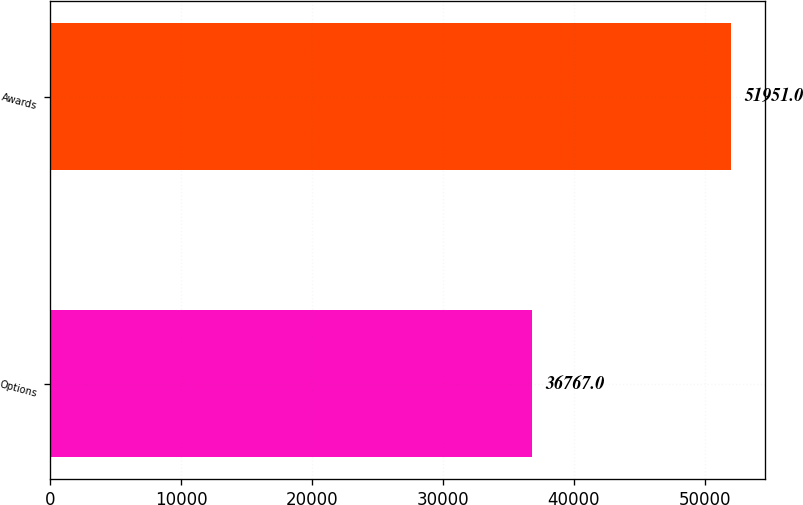Convert chart. <chart><loc_0><loc_0><loc_500><loc_500><bar_chart><fcel>Options<fcel>Awards<nl><fcel>36767<fcel>51951<nl></chart> 